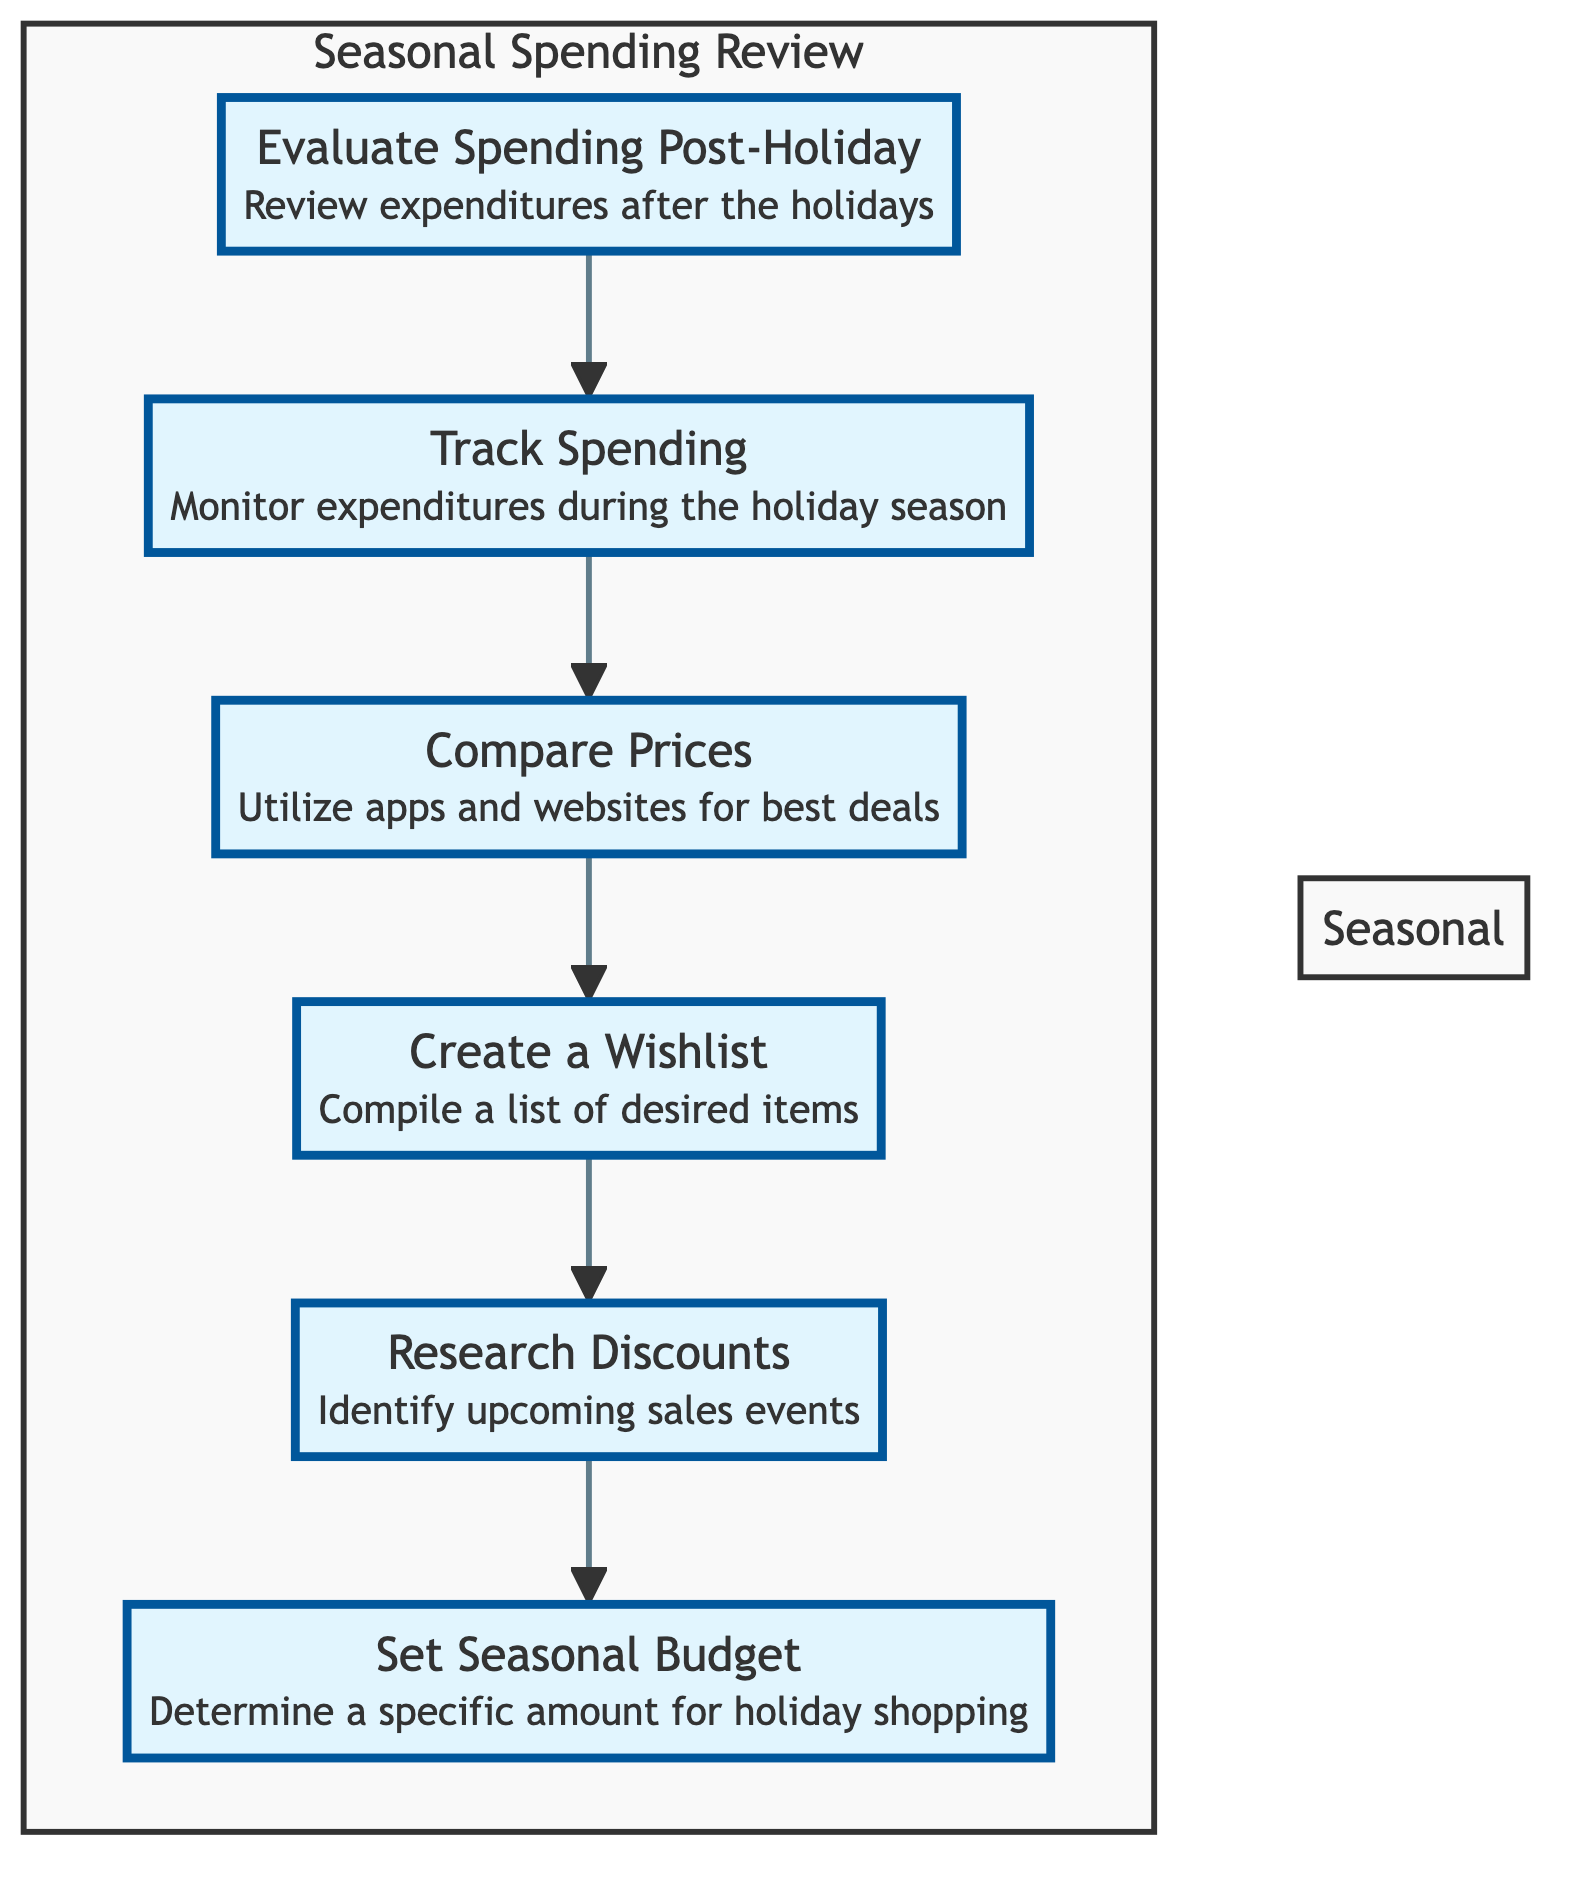what’s the first step in the Seasonal Spending Review? The first element in the flow chart is "Evaluate Spending Post-Holiday," indicating it is the initial step in the review process.
Answer: Evaluate Spending Post-Holiday how many elements are there in the diagram? There are a total of 6 elements in the flow chart related to the seasonal spending review process.
Answer: 6 what is the last step before setting the seasonal budget? The last step before "Set Seasonal Budget" is "Research Discounts," which comes immediately before it in the flow.
Answer: Research Discounts which step follows tracking spending? The step that follows "Track Spending" is "Compare Prices," indicating the sequence of actions in the diagram.
Answer: Compare Prices what is the relationship between creating a wishlist and researching discounts? "Create a Wishlist" comes before "Research Discounts" in the flow, indicating that compiling a list of desired items precedes identifying sales events.
Answer: Creating a Wishlist precedes Researching Discounts why is setting a seasonal budget the final step? Setting a seasonal budget is the final step because it determines the amount allocated for holiday shopping after evaluating previous steps, which focus on costs and prices.
Answer: It summarizes the spending plan 